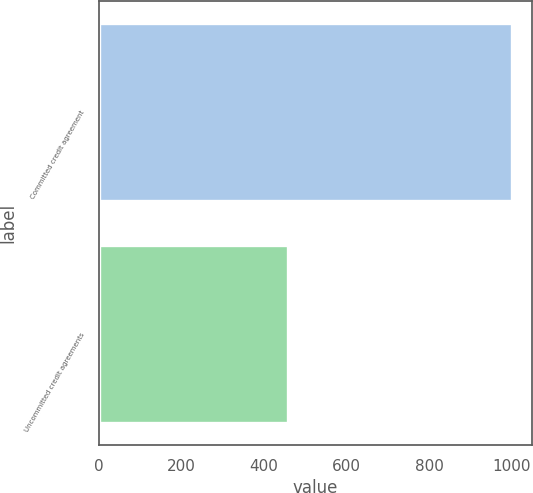<chart> <loc_0><loc_0><loc_500><loc_500><bar_chart><fcel>Committed credit agreement<fcel>Uncommitted credit agreements<nl><fcel>1000<fcel>458.3<nl></chart> 